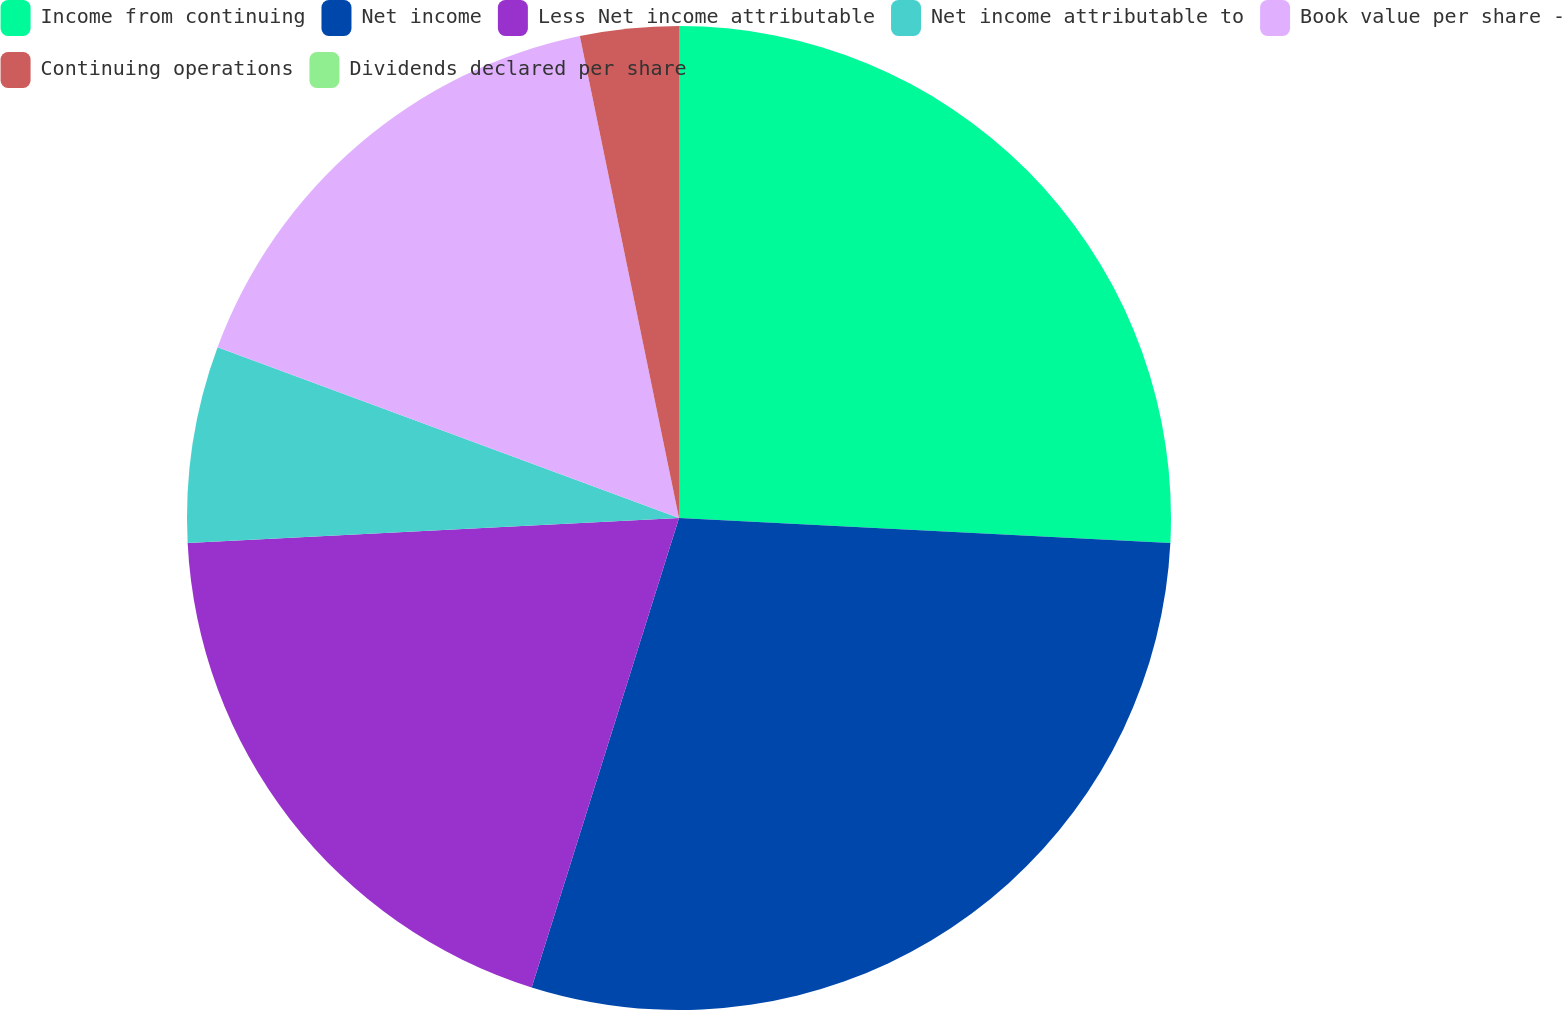<chart> <loc_0><loc_0><loc_500><loc_500><pie_chart><fcel>Income from continuing<fcel>Net income<fcel>Less Net income attributable<fcel>Net income attributable to<fcel>Book value per share -<fcel>Continuing operations<fcel>Dividends declared per share<nl><fcel>25.81%<fcel>29.03%<fcel>19.35%<fcel>6.45%<fcel>16.13%<fcel>3.23%<fcel>0.0%<nl></chart> 